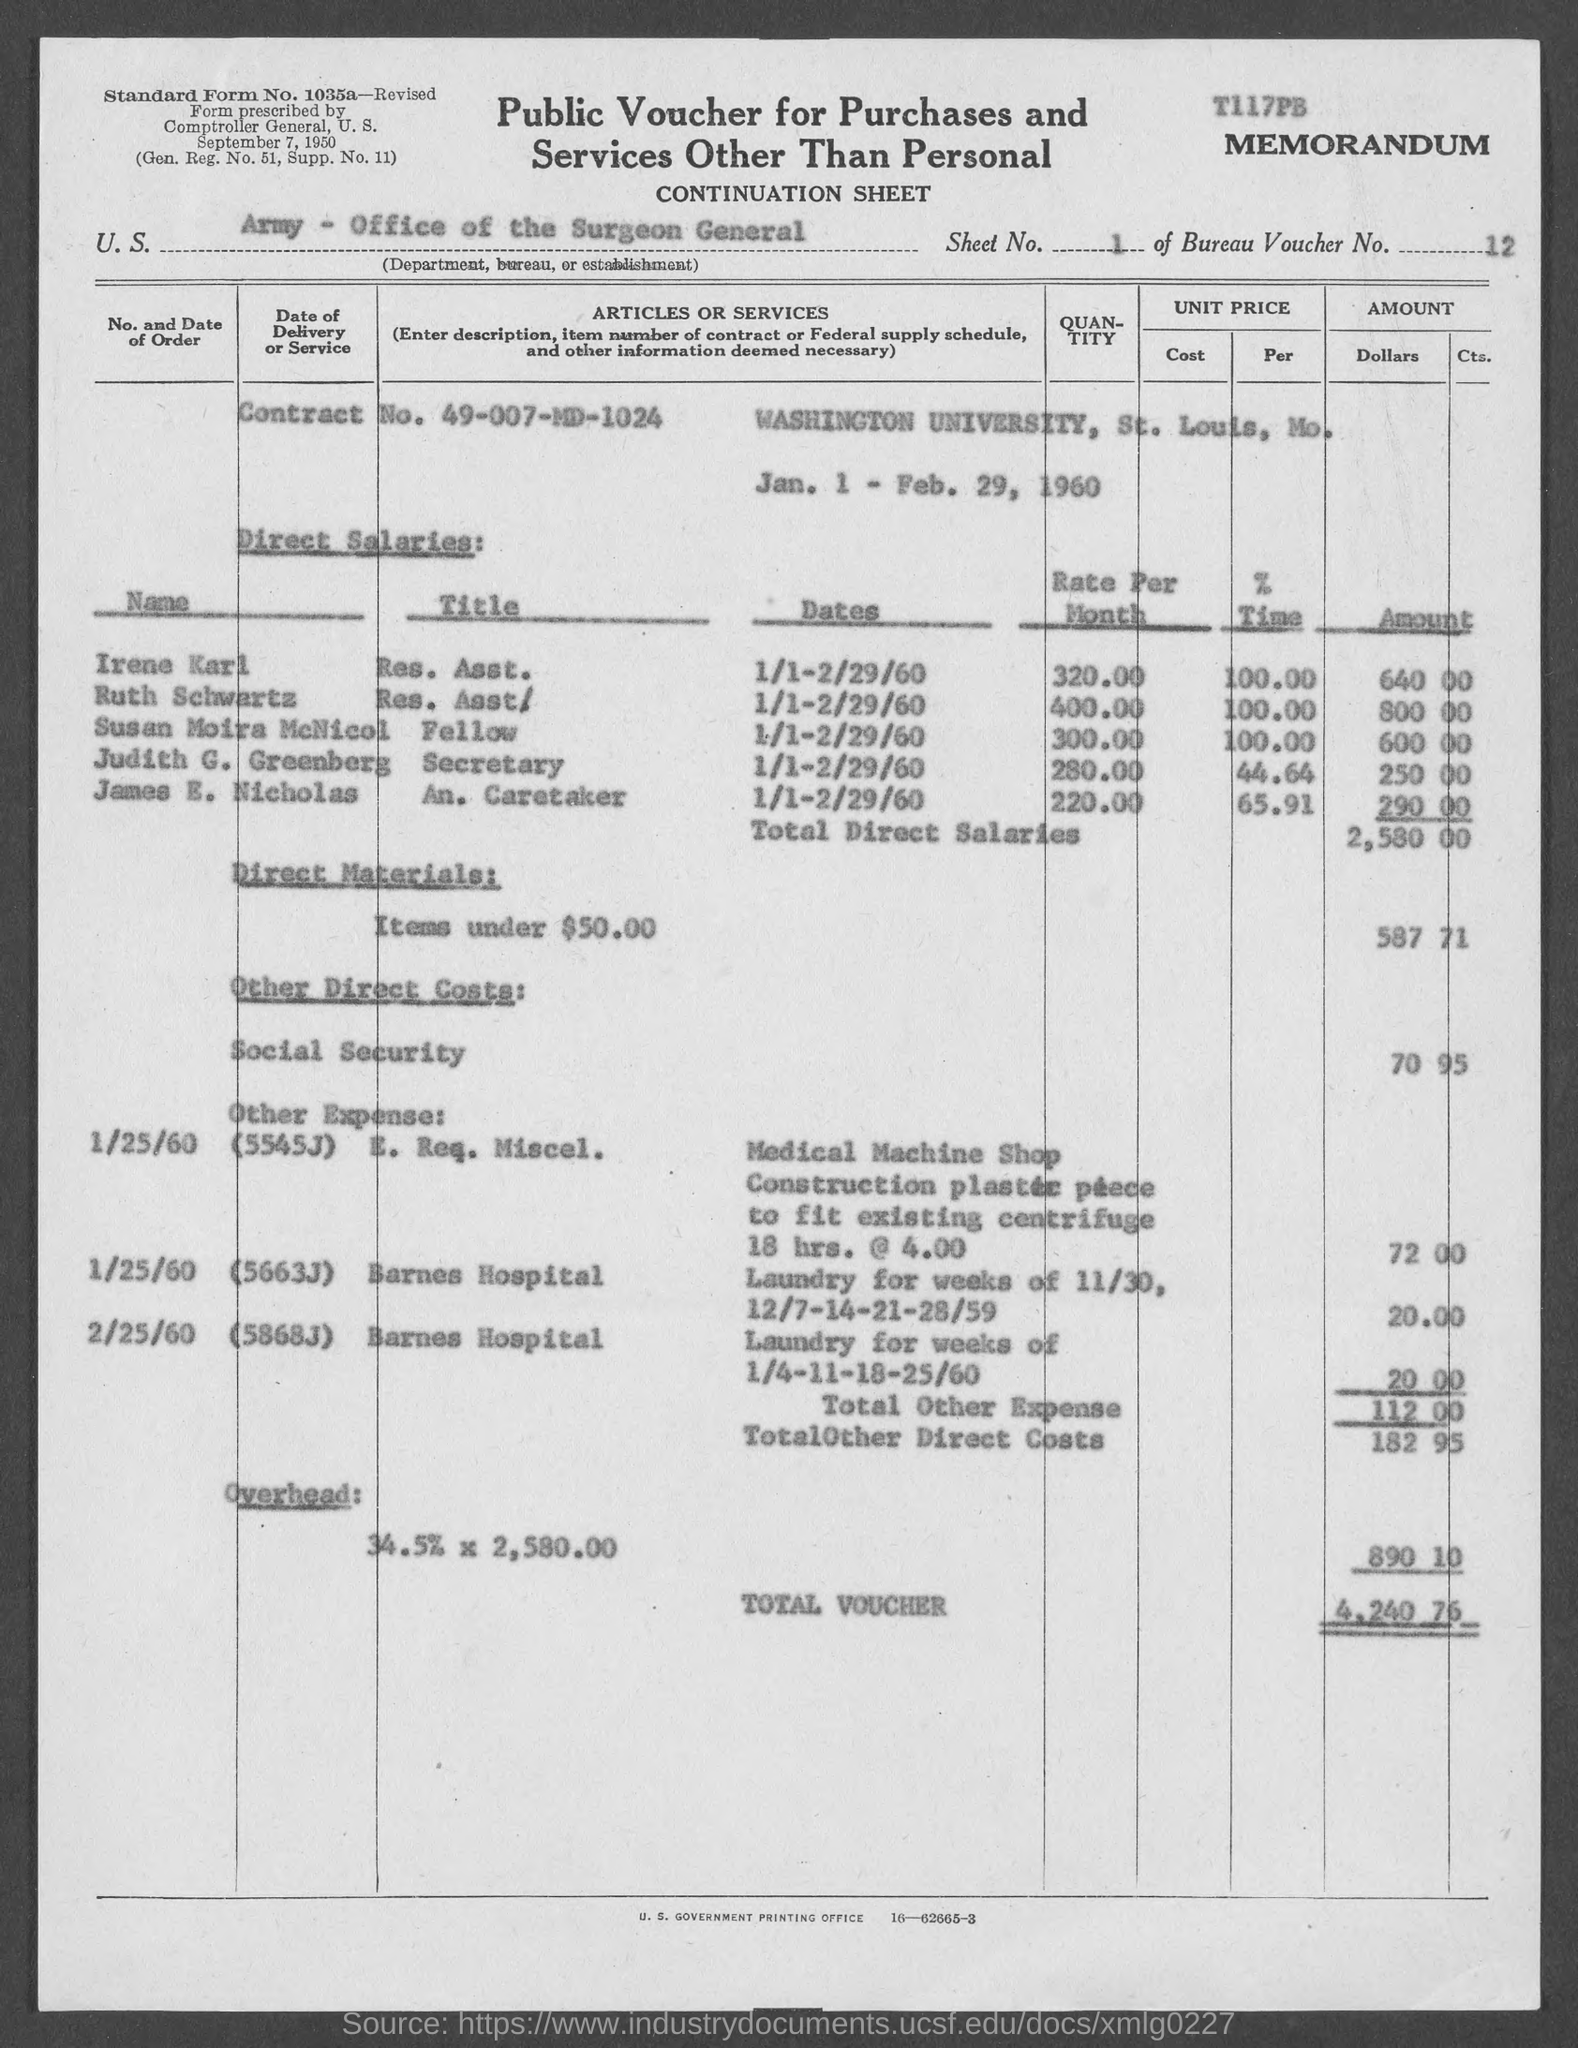What is the Sheet No.?
Ensure brevity in your answer.  1. What is the Bureau Voucher No.?
Keep it short and to the point. 12. What is the Contract No.?
Make the answer very short. 49-007-MD-1024. What are the Direct Salaries amount for Irene Karl?
Provide a succinct answer. 640 00. What are the Direct Salaries amount for Ruth Schwartz?
Offer a terse response. 800.00. What are the Direct Salaries amount for Susan Moira McNicol?
Offer a terse response. 600.00. What are the Direct Salaries amount for Judith G. Greenberg?
Give a very brief answer. 250 00. What are the Direct Salaries amount for Jmaes E. Nicholas?
Give a very brief answer. 290.00. What is the Overhead Amount?
Keep it short and to the point. 890.10. What is the Total Voucher Amount?
Ensure brevity in your answer.  4,240 76. 